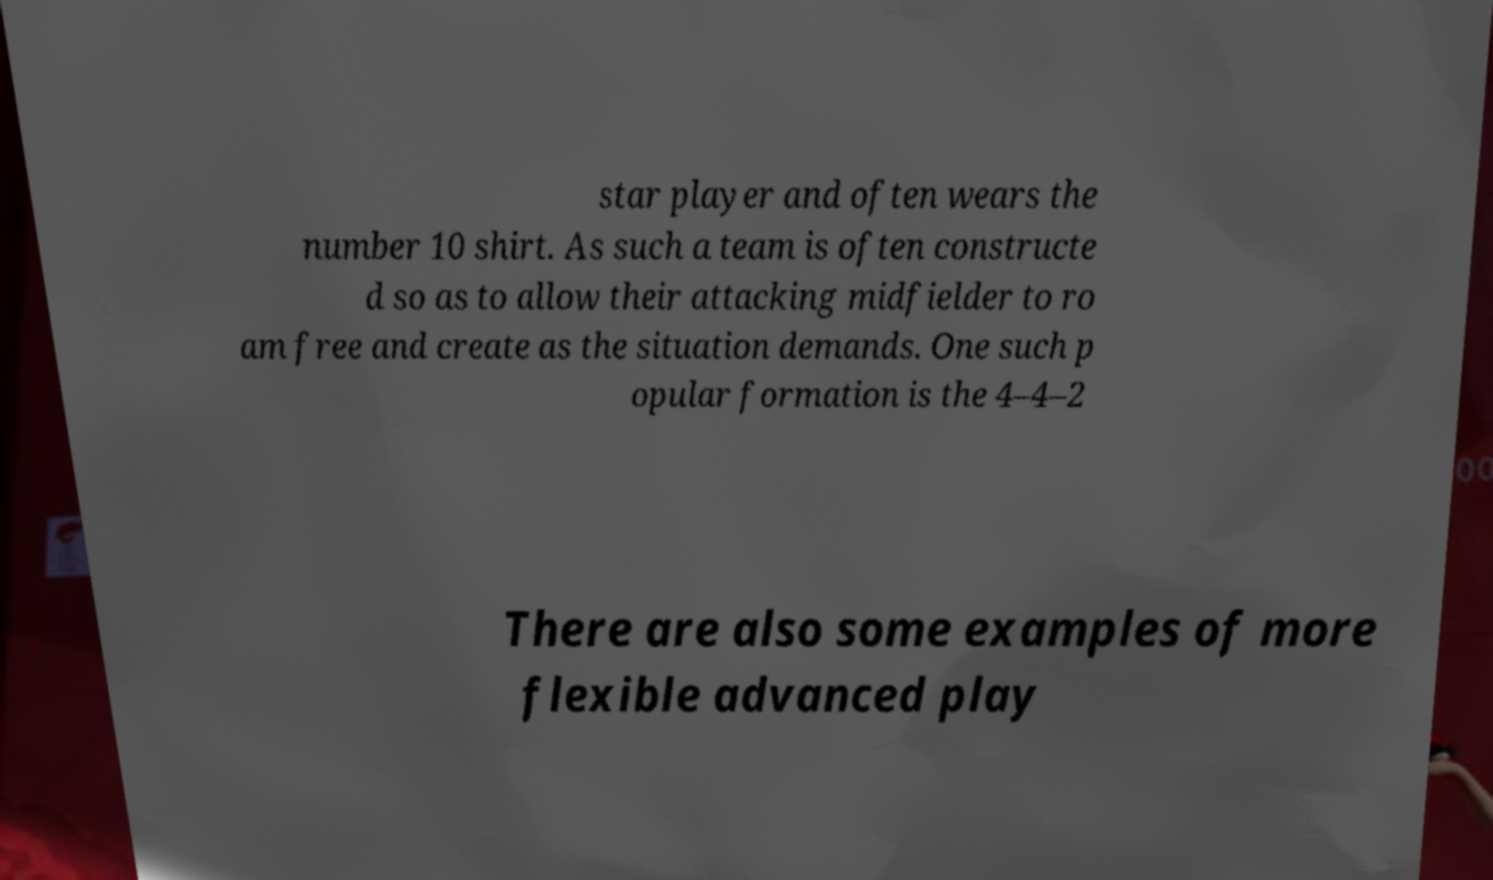There's text embedded in this image that I need extracted. Can you transcribe it verbatim? star player and often wears the number 10 shirt. As such a team is often constructe d so as to allow their attacking midfielder to ro am free and create as the situation demands. One such p opular formation is the 4–4–2 There are also some examples of more flexible advanced play 